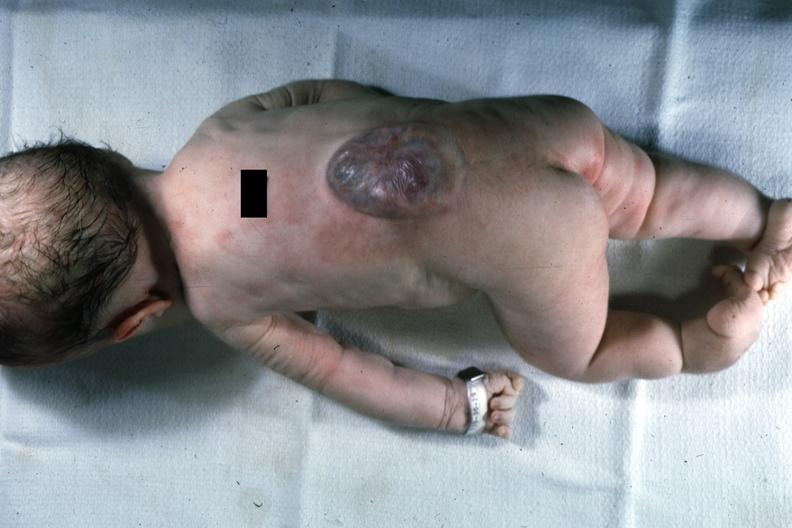how does this photo of infant from head to toe show lesion?
Answer the question using a single word or phrase. Typical 